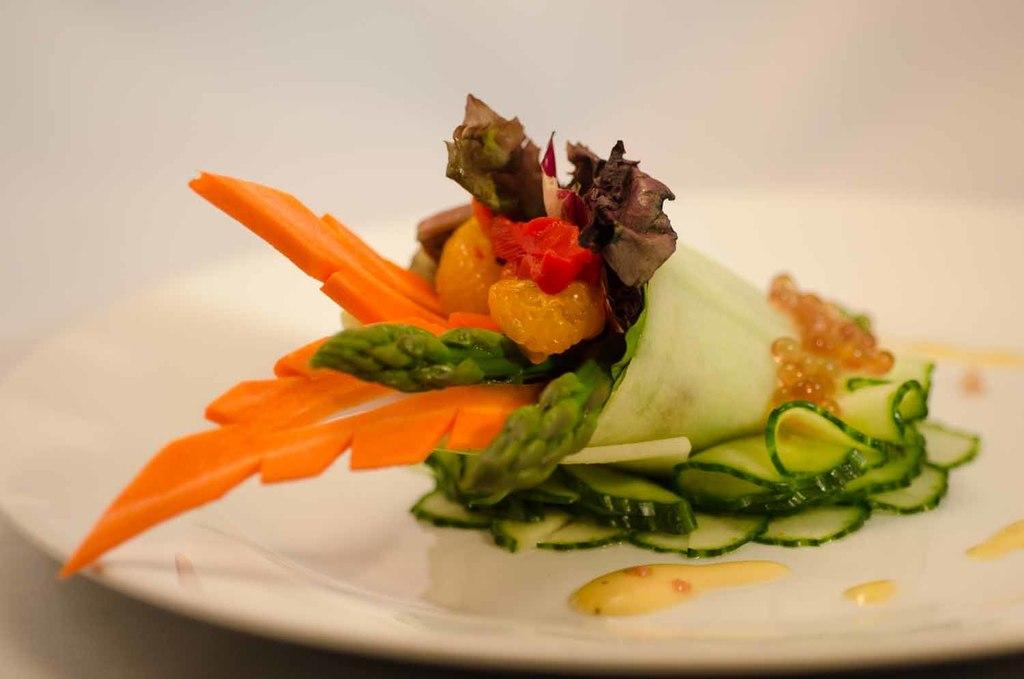What is the main subject of the image? There is a food item in the image. How is the food item presented in the image? The food item is on a plate. What color is the background of the image? The background of the image is white. What type of attraction can be seen in the background of the image? There is no attraction visible in the image; the background is white. What type of sofa is present in the image? There is no sofa present in the image; it only features a food item on a plate with a white background. 